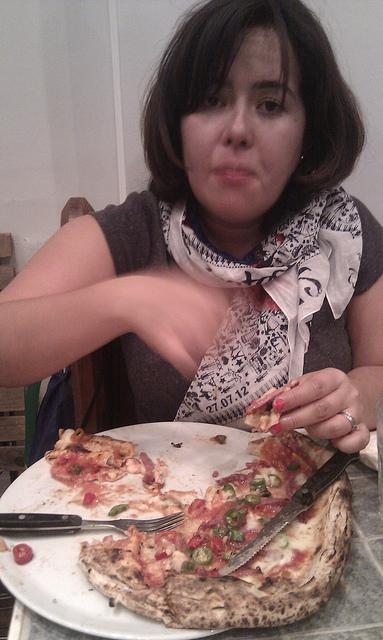Is the woman married?
Short answer required. Yes. What is the woman wearing around her neck?
Quick response, please. Scarf. What  is the woman eating?
Be succinct. Pizza. 